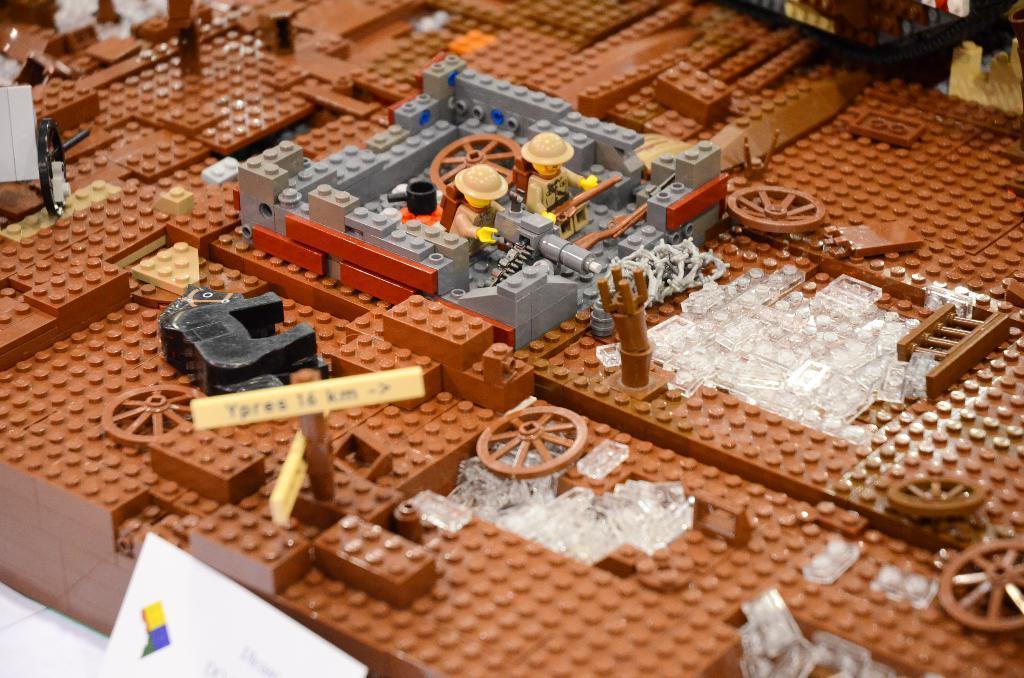Describe this image in one or two sentences. In this picture we can observe toys which were building blocks. There are two toys in which one of the toys is in front of a gun. There are three colors of blocks. They are brown, white and grey color. We can observe cream color board here. 